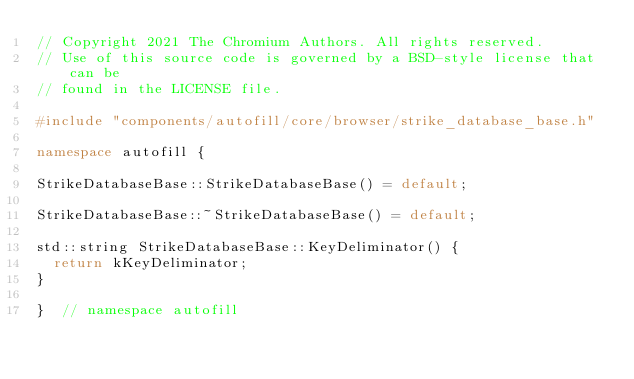Convert code to text. <code><loc_0><loc_0><loc_500><loc_500><_C++_>// Copyright 2021 The Chromium Authors. All rights reserved.
// Use of this source code is governed by a BSD-style license that can be
// found in the LICENSE file.

#include "components/autofill/core/browser/strike_database_base.h"

namespace autofill {

StrikeDatabaseBase::StrikeDatabaseBase() = default;

StrikeDatabaseBase::~StrikeDatabaseBase() = default;

std::string StrikeDatabaseBase::KeyDeliminator() {
  return kKeyDeliminator;
}

}  // namespace autofill
</code> 